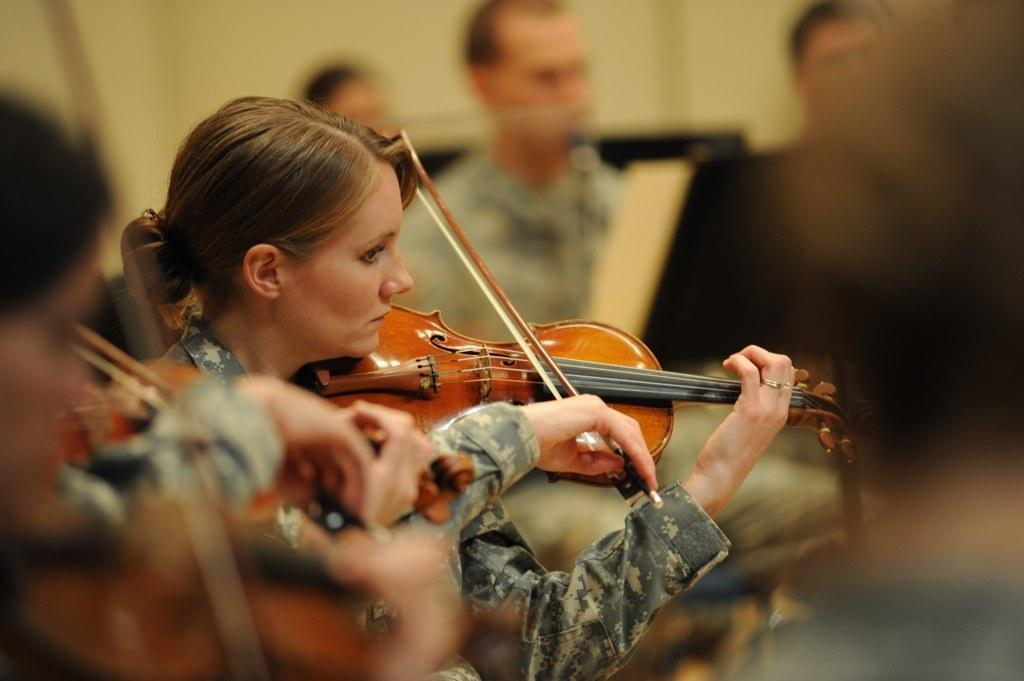How many people are in the image? There are people in the image, but the exact number is not specified. What are some of the people doing in the image? Some people are playing musical instruments in the image. What can be seen in the background of the image? There is a wall in the background of the image. Can you tell me how many yaks are visible in the image? There are no yaks present in the image. What word is being spelled out by the people in the image? There is no indication in the image that the people are spelling out a word. 